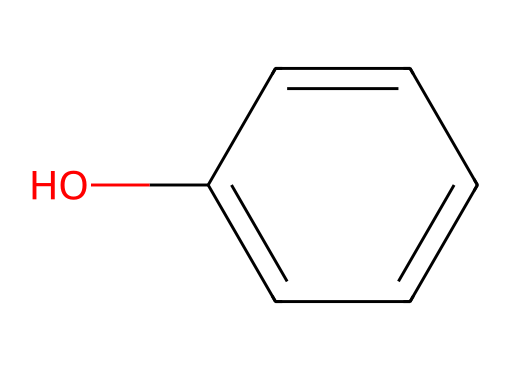What is the name of this aromatic compound? The structure shows a benzene ring with a hydroxyl group (OH) attached, which is characteristic of phenol. Therefore, the name of the compound can be identified as phenol.
Answer: phenol How many carbon atoms are there in phenol? Analyzing the molecular structure, we can count the carbon atoms represented in the benzene ring. There are six carbon atoms in total in phenol's structure.
Answer: 6 What type of functional group is present in this molecule? The presence of the hydroxyl group (OH) attached to the benzene ring identifies it as a phenolic functional group. Thus, the functional group is hydroxyl.
Answer: hydroxyl How many hydrogen atoms are in phenol? Each carbon in the aromatic ring can bond with one hydrogen atom, and since there’s one hydroxyl group replacing one hydrogen, there will be five hydrogen atoms remaining. By calculation, phenol contains five hydrogen atoms in total.
Answer: 6 Is phenol a strong or weak acid? Phenol can donate a proton due to the presence of the hydroxyl group, but its acidity is weaker than that of carboxylic acids. Hence, phenol is characterized as a weak acid.
Answer: weak acid What type of bonding exists in the phenol compound? The structure showcases alternating single and double bonds in the benzene ring, which indicates resonance and delocalization of electrons. The bonding type in phenol is mainly covalent.
Answer: covalent What reaction does phenol undergo to form a phenolate ion? The reaction involves phenol donating a proton (H+) from the hydroxyl group in an alkaline medium, leading to the formation of the phenolate ion. This indicates a deprotonation reaction.
Answer: deprotonation 